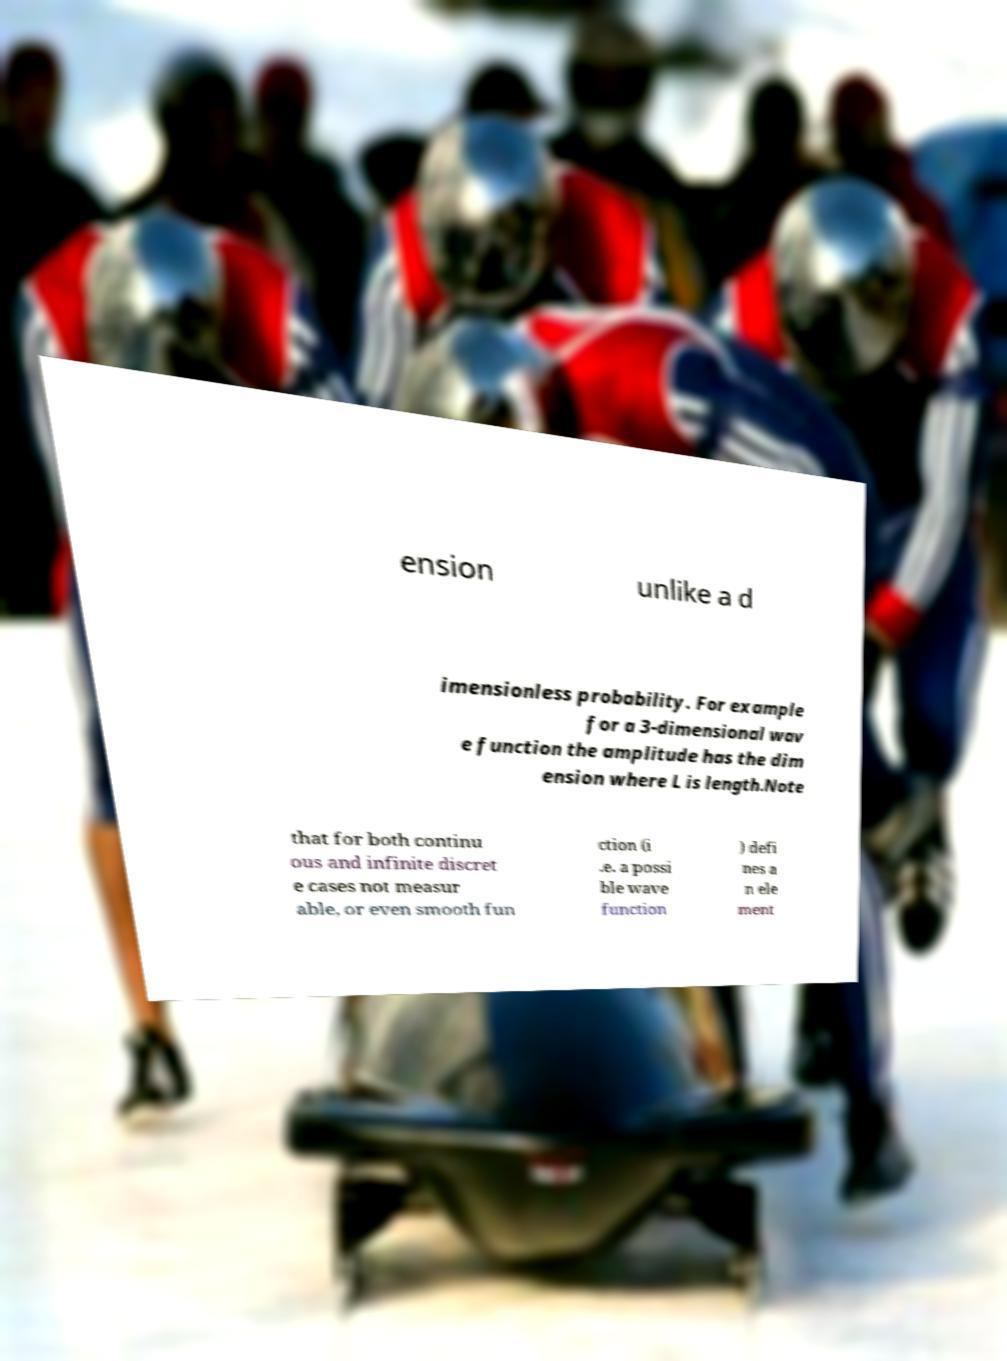Can you read and provide the text displayed in the image?This photo seems to have some interesting text. Can you extract and type it out for me? ension unlike a d imensionless probability. For example for a 3-dimensional wav e function the amplitude has the dim ension where L is length.Note that for both continu ous and infinite discret e cases not measur able, or even smooth fun ction (i .e. a possi ble wave function ) defi nes a n ele ment 